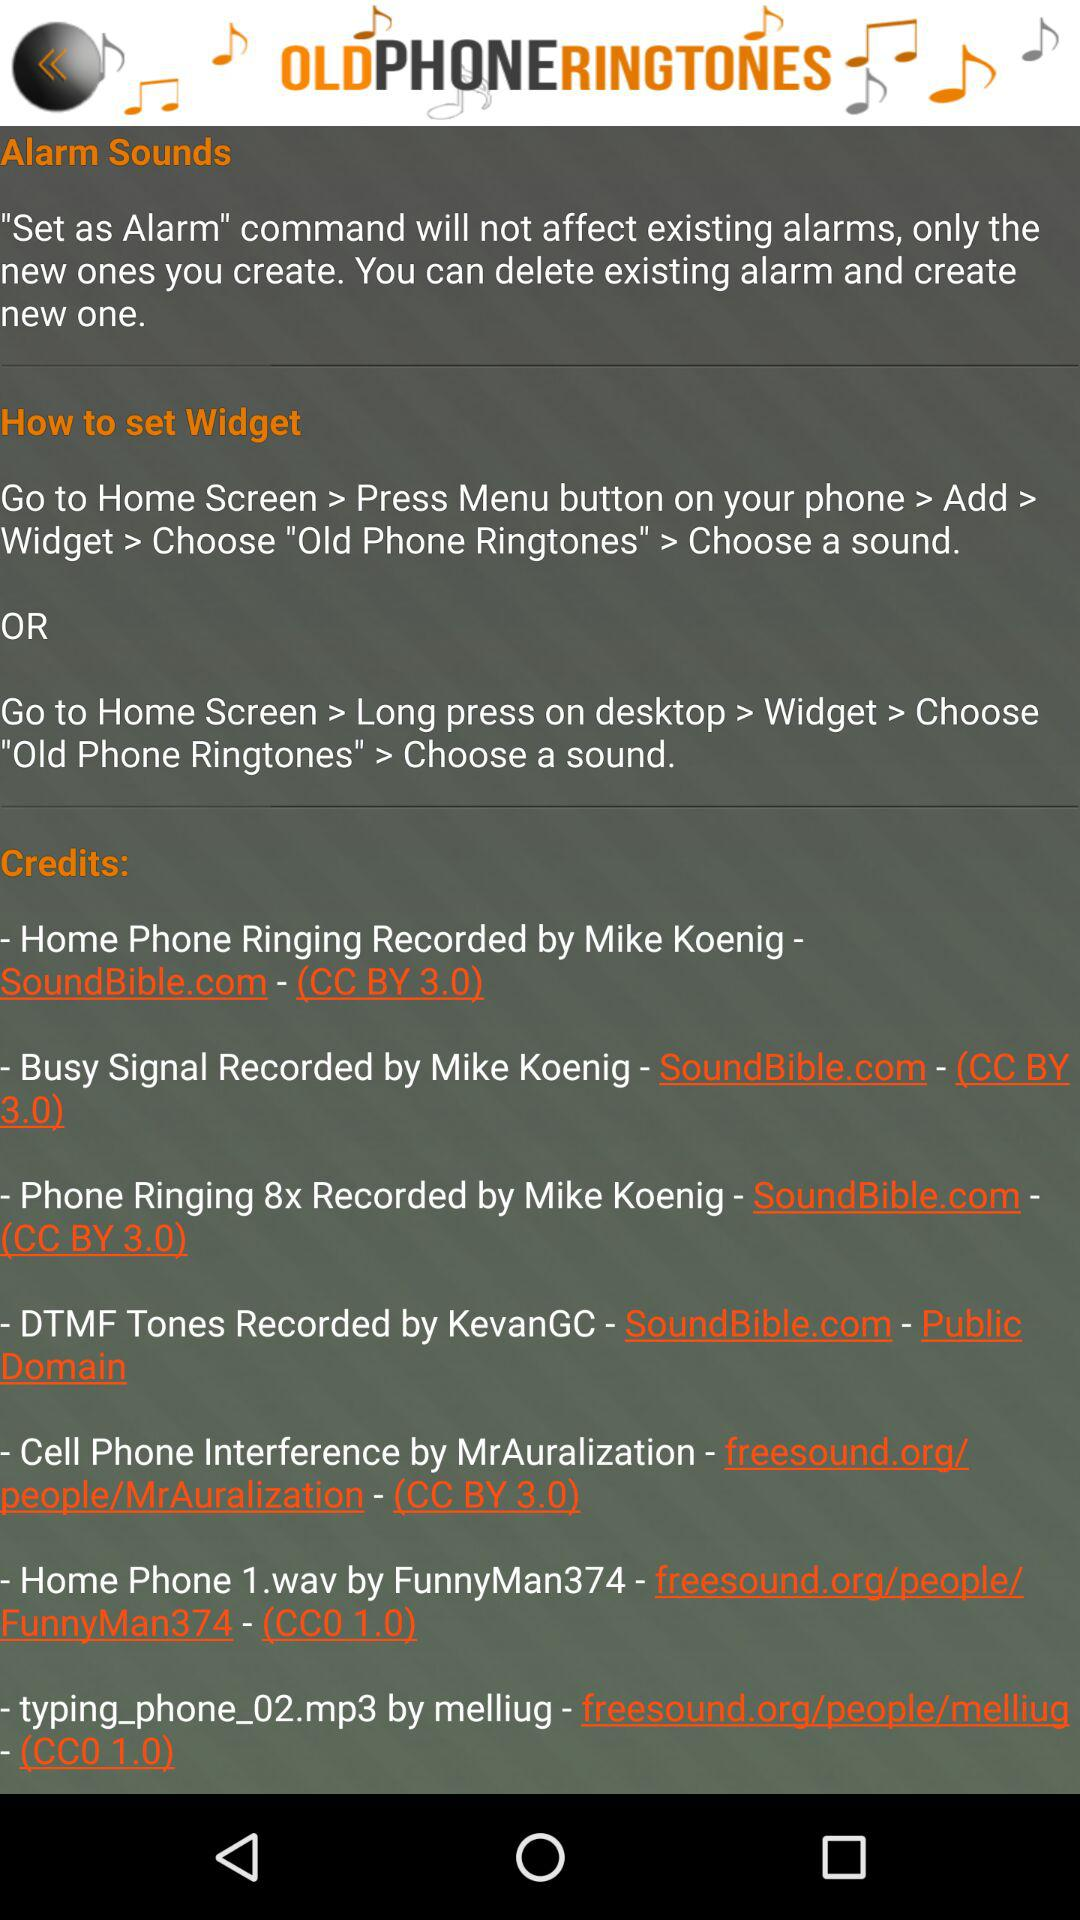Who recorded the DTMF Tones? The DTMF tones are recorded by KevanGC. 